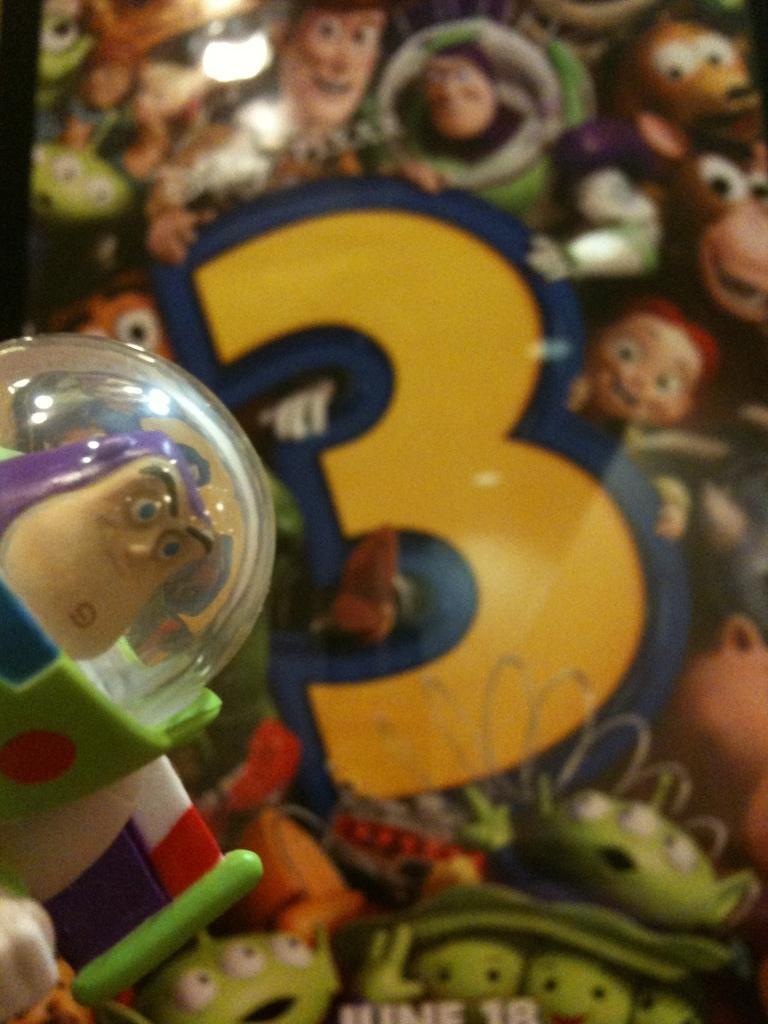Please provide a concise description of this image. In this picture I can see the toys on the table. In the back I can see the poster of the film. 